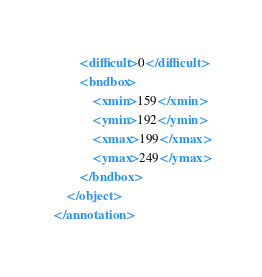<code> <loc_0><loc_0><loc_500><loc_500><_XML_>		<difficult>0</difficult>
		<bndbox>
			<xmin>159</xmin>
			<ymin>192</ymin>
			<xmax>199</xmax>
			<ymax>249</ymax>
		</bndbox>
	</object>
</annotation>
</code> 